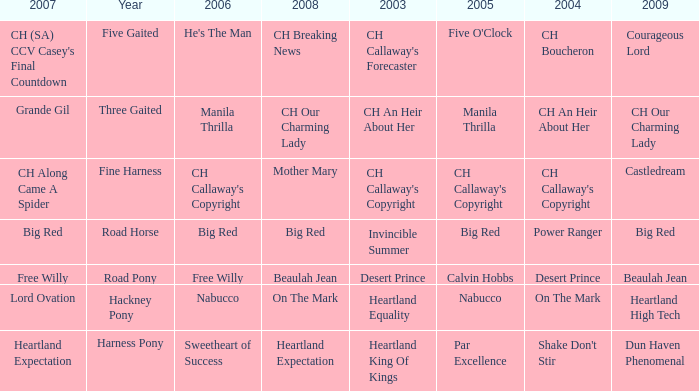What is the 2007 with ch callaway's copyright in 2003? CH Along Came A Spider. 